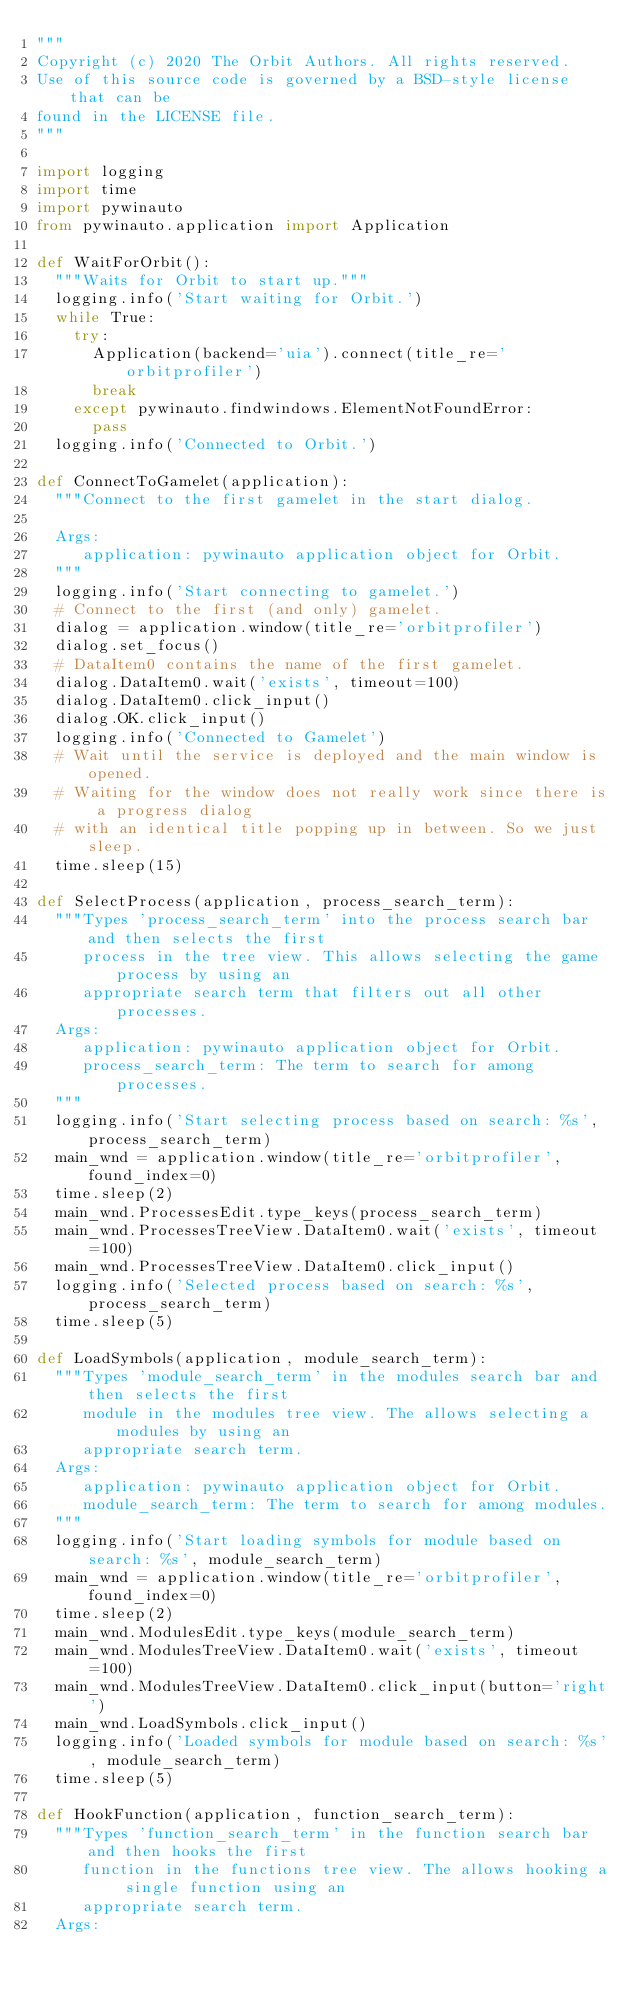Convert code to text. <code><loc_0><loc_0><loc_500><loc_500><_Python_>"""
Copyright (c) 2020 The Orbit Authors. All rights reserved.
Use of this source code is governed by a BSD-style license that can be
found in the LICENSE file.
"""

import logging
import time
import pywinauto
from pywinauto.application import Application

def WaitForOrbit():
  """Waits for Orbit to start up."""
  logging.info('Start waiting for Orbit.')
  while True:
    try:
      Application(backend='uia').connect(title_re='orbitprofiler')
      break
    except pywinauto.findwindows.ElementNotFoundError:
      pass
  logging.info('Connected to Orbit.')

def ConnectToGamelet(application):
  """Connect to the first gamelet in the start dialog.

  Args:
     application: pywinauto application object for Orbit.
  """
  logging.info('Start connecting to gamelet.')
  # Connect to the first (and only) gamelet.
  dialog = application.window(title_re='orbitprofiler')
  dialog.set_focus()
  # DataItem0 contains the name of the first gamelet.
  dialog.DataItem0.wait('exists', timeout=100)
  dialog.DataItem0.click_input()
  dialog.OK.click_input()
  logging.info('Connected to Gamelet')
  # Wait until the service is deployed and the main window is opened.
  # Waiting for the window does not really work since there is a progress dialog
  # with an identical title popping up in between. So we just sleep.
  time.sleep(15)

def SelectProcess(application, process_search_term):
  """Types 'process_search_term' into the process search bar and then selects the first
     process in the tree view. This allows selecting the game process by using an 
     appropriate search term that filters out all other processes.
  Args:
     application: pywinauto application object for Orbit.
     process_search_term: The term to search for among processes.
  """
  logging.info('Start selecting process based on search: %s', process_search_term)
  main_wnd = application.window(title_re='orbitprofiler', found_index=0)
  time.sleep(2)
  main_wnd.ProcessesEdit.type_keys(process_search_term)
  main_wnd.ProcessesTreeView.DataItem0.wait('exists', timeout=100)
  main_wnd.ProcessesTreeView.DataItem0.click_input()
  logging.info('Selected process based on search: %s', process_search_term)
  time.sleep(5)

def LoadSymbols(application, module_search_term):
  """Types 'module_search_term' in the modules search bar and then selects the first
     module in the modules tree view. The allows selecting a modules by using an 
     appropriate search term. 
  Args:
     application: pywinauto application object for Orbit.
     module_search_term: The term to search for among modules.
  """
  logging.info('Start loading symbols for module based on search: %s', module_search_term)
  main_wnd = application.window(title_re='orbitprofiler', found_index=0)
  time.sleep(2)
  main_wnd.ModulesEdit.type_keys(module_search_term)
  main_wnd.ModulesTreeView.DataItem0.wait('exists', timeout=100)
  main_wnd.ModulesTreeView.DataItem0.click_input(button='right')
  main_wnd.LoadSymbols.click_input()
  logging.info('Loaded symbols for module based on search: %s', module_search_term)
  time.sleep(5)

def HookFunction(application, function_search_term):
  """Types 'function_search_term' in the function search bar and then hooks the first
     function in the functions tree view. The allows hooking a single function using an
     appropriate search term. 
  Args:</code> 